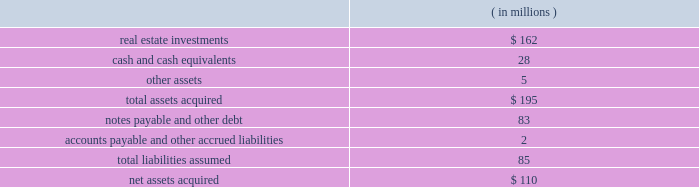Note 6 2014mergers and acquisitions eldertrust merger on february 5 , 2004 , the company consummated a merger transaction in an all cash transaction valued at $ 184 million ( the 201celdertrust transaction 201d ) .
The eldertrust transaction adds nine assisted living facilities , one independent living facility , five skilled nursing facilities , two med- ical office buildings and a financial office building ( the 201celdertrust properties 201d ) to the company 2019s portfolio.the eldertrust properties are leased by the company to various operators under leases providing for aggregated , annual cash base rent of approxi- mately $ 16.2 million , subject to escalation as provided in the leases.the leases have remaining terms primarily ranging from four to 11 years.at the closing of the eldertrust transaction , the company also acquired all of the limited partnership units in eldertrust operating limited partnership ( 201cetop 201d ) directly from their owners at $ 12.50 per unit , excluding 31455 class c units in etop ( which will remain outstanding ) .
Etop owns directly or indirectly all of the eldertrust properties .
The company funded the $ 101 million equity portion of the purchase price with cash on eldertrust 2019s balance sheet , a portion of the $ 85 million in proceeds from its december 2003 sale of ten facilities to kindred and draws on the company 2019s revolving credit facility ( the 201crevolving credit facility 201d ) under its second amended and restated security and guaranty agreement , dated as of april 17 , 2002 ( the 201c2002 credit agreement 201d ) .the company 2019s ownership of the eldertrust properties is subject to approximately $ 83 million of property level debt and other liabilities.at the close of the eldertrust transaction , eldertrust had approximately $ 33.5 million in unrestricted and restricted cash on hand .
The acquisition was accounted for under the purchase method .
The table summarizes the preliminary estimated fair values of the assets acquired and liabilities assumed at the date of acquisition .
Such estimates are subject to refinement as additional valuation information is received .
Operations from this merger will be reflected in the company 2019s consolidated financial state- ments for periods subsequent to the acquisition date of february 5 , 2004.the company is in the process of computing fair values , thus , the allocation of the purchase price is subject to refinement. .
Transaction with brookdale on january 29 , 2004 , the company entered into 14 definitive purchase agreements ( each , a 201cbrookdale purchase agreement 201d ) with certain affiliates of brookdale living communities , inc .
( 201cbrookdale 201d ) to purchase ( each such purchase , a 201cbrookdale acquisition 201d ) a total of 14 independent living or assisted living facilities ( each , a 201cbrookdale facility 201d ) for an aggregate purchase price of $ 115 million.affiliates of brookdale have agreed to lease and operate the brookdale facilities pursuant to one or more triple-net leases.all of the brookdale leases , which have an initial term of 15 years , will be guaranteed by brookdale and provide for aggregated annual base rent of approximately $ 10 million , escalating each year by the greater of ( i ) 1.5% ( 1.5 % ) or ( ii ) 75% ( 75 % ) of the consumer price index .
The company expects to fund the brookdale acquisitions by assuming an aggregate of approximately $ 41 million of non- recourse property level debt on certain of the brookdale facilities , with the balance to be paid from cash on hand and/or draws on the revolving credit facility.the property level debt encumbers seven of the brookdale facilities .
On january 29 , 2004 , the company completed the acquisitions of four brookdale facilities for an aggregate purchase price of $ 37 million.the company 2019s acquisition of the remaining ten brookdale facilities is expected to be completed shortly , subject to customary closing conditions .
However , the consummation of each such brookdale acquisition is not conditioned upon the consummation of any other such brookdale acquisition and there can be no assurance which , if any , of such remaining brookdale acquisitions will be consummated or when they will be consummated .
Transactions with trans healthcare , inc .
On november 4 , 2002 , the company , through its wholly owned subsidiary ventas realty , completed a $ 120.0 million transaction ( the 201cthi transaction 201d ) with trans healthcare , inc. , a privately owned long-term care and hospital company ( 201cthi 201d ) .the thi transaction was structured as a $ 53.0 million sale leaseback trans- action ( the 201cthi sale leaseback 201d ) and a $ 67.0 million loan ( the 201cthi loan 201d ) , comprised of a first mortgage loan ( the 201cthi senior loan 201d ) and a mezzanine loan ( the 201cthi mezzanine loan 201d ) .
Following a sale of the thi senior loan in december 2002 ( see below ) , the company 2019s investment in thi was $ 70.0 million .
As part of the thi sale leasebackventas realty purchased 5 properties and is leasing them back to thi under a 201ctriple-net 201d master lease ( the 201cthi master lease 201d ) .the properties subject to the sale leaseback are four skilled nursing facilities and one con- tinuing care retirement community.the thi master lease , which has an initial term of ten years , provides for annual base rent of $ 5.9 million.the thi master lease provides that if thi meets specified revenue parameters , annual base rent will escalate each year by the greater of ( i ) three percent or ( ii ) 50% ( 50 % ) of the consumer price index .
Ventas , inc .
Page 37 annual report 2003 .
What was the net debt to equity ratio? 
Rationale: the debt to equity ratio is the sum of the debt divided by the equity
Computations: (85 / 110)
Answer: 0.77273. 